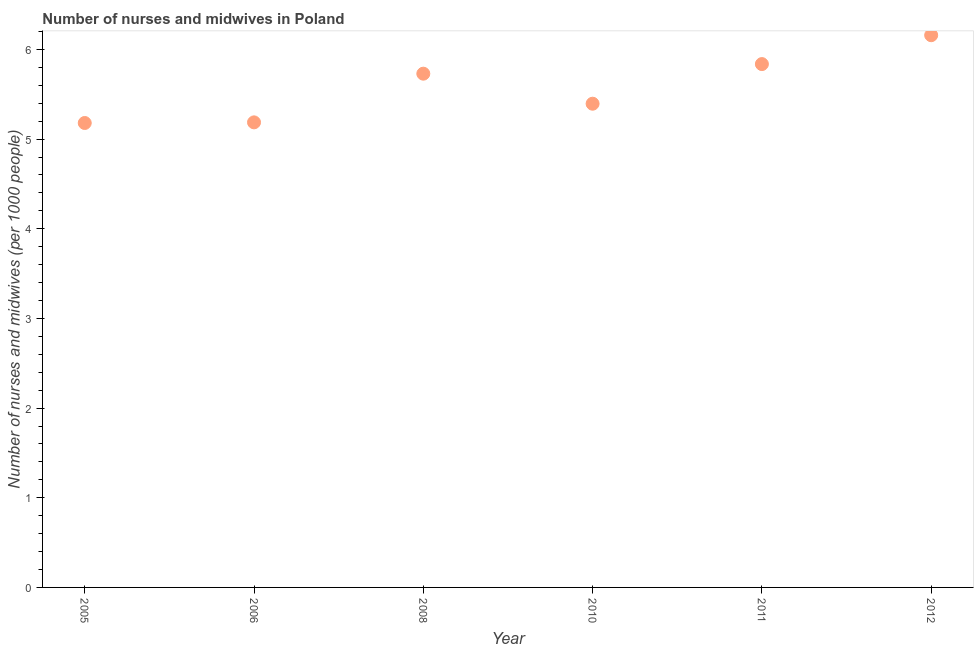What is the number of nurses and midwives in 2008?
Ensure brevity in your answer.  5.73. Across all years, what is the maximum number of nurses and midwives?
Provide a short and direct response. 6.16. Across all years, what is the minimum number of nurses and midwives?
Offer a very short reply. 5.18. In which year was the number of nurses and midwives maximum?
Give a very brief answer. 2012. In which year was the number of nurses and midwives minimum?
Your response must be concise. 2005. What is the sum of the number of nurses and midwives?
Keep it short and to the point. 33.49. What is the difference between the number of nurses and midwives in 2008 and 2010?
Keep it short and to the point. 0.34. What is the average number of nurses and midwives per year?
Keep it short and to the point. 5.58. What is the median number of nurses and midwives?
Give a very brief answer. 5.56. Do a majority of the years between 2005 and 2006 (inclusive) have number of nurses and midwives greater than 3.2 ?
Your response must be concise. Yes. What is the ratio of the number of nurses and midwives in 2005 to that in 2006?
Your answer should be very brief. 1. Is the number of nurses and midwives in 2005 less than that in 2012?
Offer a terse response. Yes. Is the difference between the number of nurses and midwives in 2006 and 2010 greater than the difference between any two years?
Offer a very short reply. No. What is the difference between the highest and the second highest number of nurses and midwives?
Your answer should be very brief. 0.32. What is the difference between the highest and the lowest number of nurses and midwives?
Make the answer very short. 0.98. Does the number of nurses and midwives monotonically increase over the years?
Your response must be concise. No. What is the difference between two consecutive major ticks on the Y-axis?
Your response must be concise. 1. Are the values on the major ticks of Y-axis written in scientific E-notation?
Give a very brief answer. No. Does the graph contain any zero values?
Your answer should be very brief. No. Does the graph contain grids?
Keep it short and to the point. No. What is the title of the graph?
Your answer should be very brief. Number of nurses and midwives in Poland. What is the label or title of the X-axis?
Make the answer very short. Year. What is the label or title of the Y-axis?
Keep it short and to the point. Number of nurses and midwives (per 1000 people). What is the Number of nurses and midwives (per 1000 people) in 2005?
Your answer should be very brief. 5.18. What is the Number of nurses and midwives (per 1000 people) in 2006?
Your response must be concise. 5.19. What is the Number of nurses and midwives (per 1000 people) in 2008?
Offer a terse response. 5.73. What is the Number of nurses and midwives (per 1000 people) in 2010?
Provide a succinct answer. 5.39. What is the Number of nurses and midwives (per 1000 people) in 2011?
Ensure brevity in your answer.  5.84. What is the Number of nurses and midwives (per 1000 people) in 2012?
Make the answer very short. 6.16. What is the difference between the Number of nurses and midwives (per 1000 people) in 2005 and 2006?
Provide a succinct answer. -0.01. What is the difference between the Number of nurses and midwives (per 1000 people) in 2005 and 2008?
Keep it short and to the point. -0.55. What is the difference between the Number of nurses and midwives (per 1000 people) in 2005 and 2010?
Provide a short and direct response. -0.21. What is the difference between the Number of nurses and midwives (per 1000 people) in 2005 and 2011?
Your answer should be compact. -0.66. What is the difference between the Number of nurses and midwives (per 1000 people) in 2005 and 2012?
Your response must be concise. -0.98. What is the difference between the Number of nurses and midwives (per 1000 people) in 2006 and 2008?
Offer a terse response. -0.54. What is the difference between the Number of nurses and midwives (per 1000 people) in 2006 and 2010?
Your answer should be very brief. -0.21. What is the difference between the Number of nurses and midwives (per 1000 people) in 2006 and 2011?
Offer a very short reply. -0.65. What is the difference between the Number of nurses and midwives (per 1000 people) in 2006 and 2012?
Offer a very short reply. -0.97. What is the difference between the Number of nurses and midwives (per 1000 people) in 2008 and 2010?
Keep it short and to the point. 0.34. What is the difference between the Number of nurses and midwives (per 1000 people) in 2008 and 2011?
Offer a very short reply. -0.11. What is the difference between the Number of nurses and midwives (per 1000 people) in 2008 and 2012?
Make the answer very short. -0.43. What is the difference between the Number of nurses and midwives (per 1000 people) in 2010 and 2011?
Give a very brief answer. -0.44. What is the difference between the Number of nurses and midwives (per 1000 people) in 2010 and 2012?
Give a very brief answer. -0.76. What is the difference between the Number of nurses and midwives (per 1000 people) in 2011 and 2012?
Make the answer very short. -0.32. What is the ratio of the Number of nurses and midwives (per 1000 people) in 2005 to that in 2006?
Ensure brevity in your answer.  1. What is the ratio of the Number of nurses and midwives (per 1000 people) in 2005 to that in 2008?
Your response must be concise. 0.9. What is the ratio of the Number of nurses and midwives (per 1000 people) in 2005 to that in 2011?
Offer a terse response. 0.89. What is the ratio of the Number of nurses and midwives (per 1000 people) in 2005 to that in 2012?
Make the answer very short. 0.84. What is the ratio of the Number of nurses and midwives (per 1000 people) in 2006 to that in 2008?
Your answer should be very brief. 0.91. What is the ratio of the Number of nurses and midwives (per 1000 people) in 2006 to that in 2011?
Offer a terse response. 0.89. What is the ratio of the Number of nurses and midwives (per 1000 people) in 2006 to that in 2012?
Ensure brevity in your answer.  0.84. What is the ratio of the Number of nurses and midwives (per 1000 people) in 2008 to that in 2010?
Give a very brief answer. 1.06. What is the ratio of the Number of nurses and midwives (per 1000 people) in 2010 to that in 2011?
Offer a terse response. 0.92. What is the ratio of the Number of nurses and midwives (per 1000 people) in 2010 to that in 2012?
Keep it short and to the point. 0.88. What is the ratio of the Number of nurses and midwives (per 1000 people) in 2011 to that in 2012?
Offer a very short reply. 0.95. 